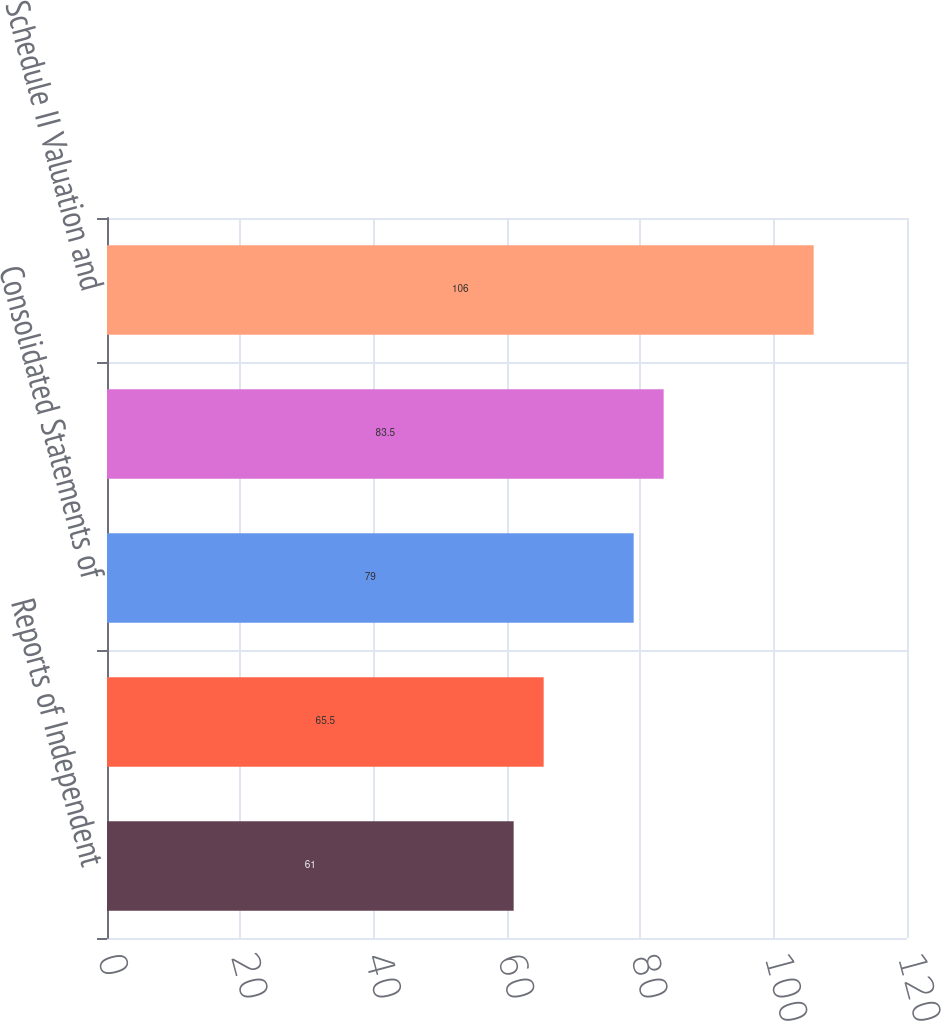Convert chart to OTSL. <chart><loc_0><loc_0><loc_500><loc_500><bar_chart><fcel>Reports of Independent<fcel>Consolidated Balance Sheets as<fcel>Consolidated Statements of<fcel>Notes to Consolidated<fcel>Schedule II Valuation and<nl><fcel>61<fcel>65.5<fcel>79<fcel>83.5<fcel>106<nl></chart> 